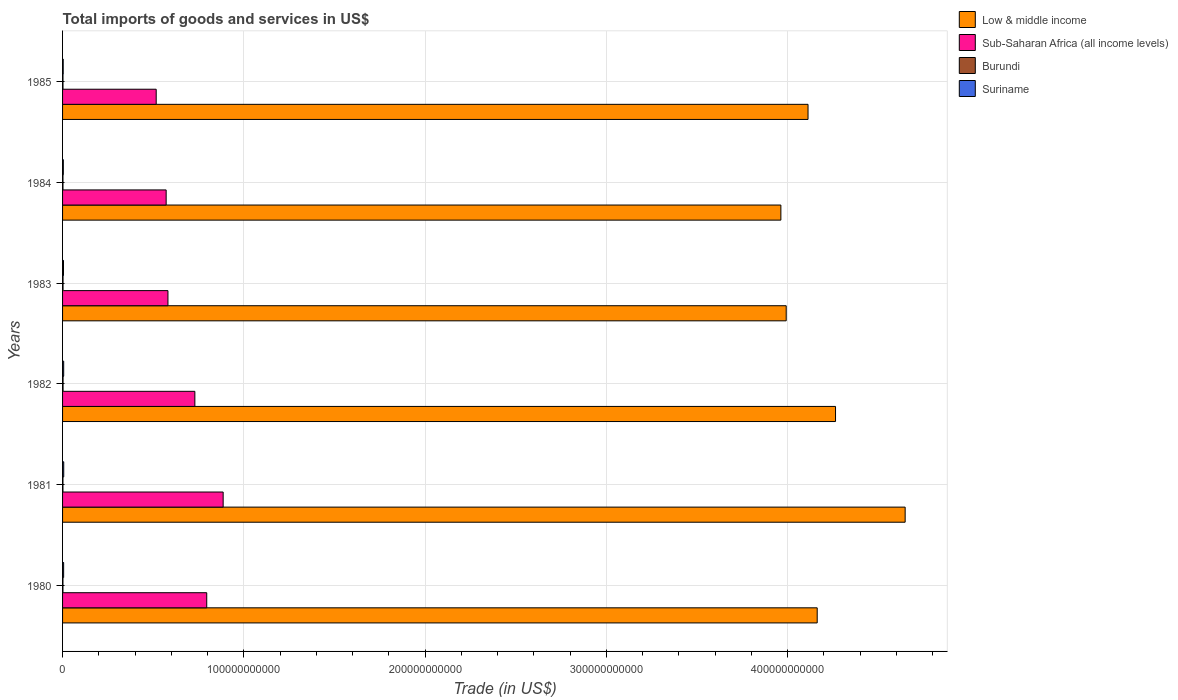How many different coloured bars are there?
Give a very brief answer. 4. How many groups of bars are there?
Ensure brevity in your answer.  6. How many bars are there on the 2nd tick from the top?
Offer a very short reply. 4. What is the total imports of goods and services in Suriname in 1981?
Offer a terse response. 6.46e+08. Across all years, what is the maximum total imports of goods and services in Burundi?
Your response must be concise. 2.73e+08. Across all years, what is the minimum total imports of goods and services in Low & middle income?
Your response must be concise. 3.96e+11. In which year was the total imports of goods and services in Sub-Saharan Africa (all income levels) minimum?
Keep it short and to the point. 1985. What is the total total imports of goods and services in Sub-Saharan Africa (all income levels) in the graph?
Your answer should be compact. 4.08e+11. What is the difference between the total imports of goods and services in Sub-Saharan Africa (all income levels) in 1982 and that in 1984?
Give a very brief answer. 1.58e+1. What is the difference between the total imports of goods and services in Suriname in 1981 and the total imports of goods and services in Sub-Saharan Africa (all income levels) in 1985?
Ensure brevity in your answer.  -5.10e+1. What is the average total imports of goods and services in Burundi per year?
Make the answer very short. 2.40e+08. In the year 1981, what is the difference between the total imports of goods and services in Sub-Saharan Africa (all income levels) and total imports of goods and services in Suriname?
Offer a terse response. 8.80e+1. In how many years, is the total imports of goods and services in Burundi greater than 60000000000 US$?
Provide a short and direct response. 0. What is the ratio of the total imports of goods and services in Low & middle income in 1981 to that in 1984?
Ensure brevity in your answer.  1.17. Is the total imports of goods and services in Sub-Saharan Africa (all income levels) in 1982 less than that in 1984?
Provide a succinct answer. No. What is the difference between the highest and the second highest total imports of goods and services in Suriname?
Provide a short and direct response. 3.05e+07. What is the difference between the highest and the lowest total imports of goods and services in Sub-Saharan Africa (all income levels)?
Give a very brief answer. 3.69e+1. In how many years, is the total imports of goods and services in Burundi greater than the average total imports of goods and services in Burundi taken over all years?
Ensure brevity in your answer.  2. What does the 4th bar from the bottom in 1981 represents?
Your answer should be compact. Suriname. Is it the case that in every year, the sum of the total imports of goods and services in Suriname and total imports of goods and services in Sub-Saharan Africa (all income levels) is greater than the total imports of goods and services in Burundi?
Your response must be concise. Yes. How many bars are there?
Keep it short and to the point. 24. Are all the bars in the graph horizontal?
Offer a very short reply. Yes. How many years are there in the graph?
Make the answer very short. 6. What is the difference between two consecutive major ticks on the X-axis?
Offer a very short reply. 1.00e+11. Does the graph contain any zero values?
Provide a short and direct response. No. Does the graph contain grids?
Make the answer very short. Yes. What is the title of the graph?
Make the answer very short. Total imports of goods and services in US$. What is the label or title of the X-axis?
Offer a very short reply. Trade (in US$). What is the Trade (in US$) of Low & middle income in 1980?
Provide a short and direct response. 4.16e+11. What is the Trade (in US$) in Sub-Saharan Africa (all income levels) in 1980?
Provide a short and direct response. 7.95e+1. What is the Trade (in US$) of Burundi in 1980?
Give a very brief answer. 2.14e+08. What is the Trade (in US$) of Suriname in 1980?
Give a very brief answer. 5.90e+08. What is the Trade (in US$) of Low & middle income in 1981?
Provide a succinct answer. 4.65e+11. What is the Trade (in US$) of Sub-Saharan Africa (all income levels) in 1981?
Make the answer very short. 8.86e+1. What is the Trade (in US$) in Burundi in 1981?
Provide a short and direct response. 2.14e+08. What is the Trade (in US$) in Suriname in 1981?
Your answer should be compact. 6.46e+08. What is the Trade (in US$) of Low & middle income in 1982?
Ensure brevity in your answer.  4.26e+11. What is the Trade (in US$) of Sub-Saharan Africa (all income levels) in 1982?
Your answer should be very brief. 7.30e+1. What is the Trade (in US$) of Burundi in 1982?
Your response must be concise. 2.73e+08. What is the Trade (in US$) of Suriname in 1982?
Offer a very short reply. 6.16e+08. What is the Trade (in US$) of Low & middle income in 1983?
Offer a very short reply. 3.99e+11. What is the Trade (in US$) in Sub-Saharan Africa (all income levels) in 1983?
Your response must be concise. 5.81e+1. What is the Trade (in US$) of Burundi in 1983?
Give a very brief answer. 2.68e+08. What is the Trade (in US$) of Suriname in 1983?
Make the answer very short. 5.18e+08. What is the Trade (in US$) of Low & middle income in 1984?
Keep it short and to the point. 3.96e+11. What is the Trade (in US$) in Sub-Saharan Africa (all income levels) in 1984?
Offer a terse response. 5.72e+1. What is the Trade (in US$) of Burundi in 1984?
Make the answer very short. 2.32e+08. What is the Trade (in US$) of Suriname in 1984?
Give a very brief answer. 4.22e+08. What is the Trade (in US$) of Low & middle income in 1985?
Offer a very short reply. 4.11e+11. What is the Trade (in US$) in Sub-Saharan Africa (all income levels) in 1985?
Keep it short and to the point. 5.17e+1. What is the Trade (in US$) in Burundi in 1985?
Your response must be concise. 2.39e+08. What is the Trade (in US$) in Suriname in 1985?
Your response must be concise. 3.48e+08. Across all years, what is the maximum Trade (in US$) of Low & middle income?
Ensure brevity in your answer.  4.65e+11. Across all years, what is the maximum Trade (in US$) in Sub-Saharan Africa (all income levels)?
Your answer should be compact. 8.86e+1. Across all years, what is the maximum Trade (in US$) in Burundi?
Provide a short and direct response. 2.73e+08. Across all years, what is the maximum Trade (in US$) of Suriname?
Ensure brevity in your answer.  6.46e+08. Across all years, what is the minimum Trade (in US$) of Low & middle income?
Give a very brief answer. 3.96e+11. Across all years, what is the minimum Trade (in US$) in Sub-Saharan Africa (all income levels)?
Ensure brevity in your answer.  5.17e+1. Across all years, what is the minimum Trade (in US$) in Burundi?
Keep it short and to the point. 2.14e+08. Across all years, what is the minimum Trade (in US$) in Suriname?
Provide a succinct answer. 3.48e+08. What is the total Trade (in US$) of Low & middle income in the graph?
Make the answer very short. 2.51e+12. What is the total Trade (in US$) of Sub-Saharan Africa (all income levels) in the graph?
Ensure brevity in your answer.  4.08e+11. What is the total Trade (in US$) of Burundi in the graph?
Your answer should be very brief. 1.44e+09. What is the total Trade (in US$) in Suriname in the graph?
Keep it short and to the point. 3.14e+09. What is the difference between the Trade (in US$) of Low & middle income in 1980 and that in 1981?
Offer a very short reply. -4.85e+1. What is the difference between the Trade (in US$) of Sub-Saharan Africa (all income levels) in 1980 and that in 1981?
Provide a short and direct response. -9.06e+09. What is the difference between the Trade (in US$) in Burundi in 1980 and that in 1981?
Keep it short and to the point. 6.68e+05. What is the difference between the Trade (in US$) of Suriname in 1980 and that in 1981?
Provide a short and direct response. -5.60e+07. What is the difference between the Trade (in US$) in Low & middle income in 1980 and that in 1982?
Your answer should be compact. -1.01e+1. What is the difference between the Trade (in US$) of Sub-Saharan Africa (all income levels) in 1980 and that in 1982?
Provide a succinct answer. 6.55e+09. What is the difference between the Trade (in US$) in Burundi in 1980 and that in 1982?
Your answer should be very brief. -5.84e+07. What is the difference between the Trade (in US$) of Suriname in 1980 and that in 1982?
Provide a short and direct response. -2.55e+07. What is the difference between the Trade (in US$) of Low & middle income in 1980 and that in 1983?
Your answer should be very brief. 1.71e+1. What is the difference between the Trade (in US$) of Sub-Saharan Africa (all income levels) in 1980 and that in 1983?
Your response must be concise. 2.14e+1. What is the difference between the Trade (in US$) in Burundi in 1980 and that in 1983?
Ensure brevity in your answer.  -5.38e+07. What is the difference between the Trade (in US$) of Suriname in 1980 and that in 1983?
Give a very brief answer. 7.24e+07. What is the difference between the Trade (in US$) in Low & middle income in 1980 and that in 1984?
Provide a short and direct response. 2.00e+1. What is the difference between the Trade (in US$) of Sub-Saharan Africa (all income levels) in 1980 and that in 1984?
Offer a very short reply. 2.24e+1. What is the difference between the Trade (in US$) of Burundi in 1980 and that in 1984?
Your answer should be compact. -1.83e+07. What is the difference between the Trade (in US$) in Suriname in 1980 and that in 1984?
Offer a very short reply. 1.68e+08. What is the difference between the Trade (in US$) of Low & middle income in 1980 and that in 1985?
Keep it short and to the point. 5.06e+09. What is the difference between the Trade (in US$) in Sub-Saharan Africa (all income levels) in 1980 and that in 1985?
Give a very brief answer. 2.79e+1. What is the difference between the Trade (in US$) in Burundi in 1980 and that in 1985?
Make the answer very short. -2.48e+07. What is the difference between the Trade (in US$) in Suriname in 1980 and that in 1985?
Give a very brief answer. 2.42e+08. What is the difference between the Trade (in US$) in Low & middle income in 1981 and that in 1982?
Make the answer very short. 3.84e+1. What is the difference between the Trade (in US$) of Sub-Saharan Africa (all income levels) in 1981 and that in 1982?
Keep it short and to the point. 1.56e+1. What is the difference between the Trade (in US$) of Burundi in 1981 and that in 1982?
Offer a very short reply. -5.91e+07. What is the difference between the Trade (in US$) of Suriname in 1981 and that in 1982?
Keep it short and to the point. 3.05e+07. What is the difference between the Trade (in US$) of Low & middle income in 1981 and that in 1983?
Make the answer very short. 6.56e+1. What is the difference between the Trade (in US$) of Sub-Saharan Africa (all income levels) in 1981 and that in 1983?
Offer a terse response. 3.05e+1. What is the difference between the Trade (in US$) of Burundi in 1981 and that in 1983?
Your answer should be very brief. -5.44e+07. What is the difference between the Trade (in US$) of Suriname in 1981 and that in 1983?
Your answer should be compact. 1.28e+08. What is the difference between the Trade (in US$) of Low & middle income in 1981 and that in 1984?
Provide a succinct answer. 6.86e+1. What is the difference between the Trade (in US$) in Sub-Saharan Africa (all income levels) in 1981 and that in 1984?
Your answer should be very brief. 3.14e+1. What is the difference between the Trade (in US$) in Burundi in 1981 and that in 1984?
Your answer should be compact. -1.89e+07. What is the difference between the Trade (in US$) of Suriname in 1981 and that in 1984?
Keep it short and to the point. 2.24e+08. What is the difference between the Trade (in US$) of Low & middle income in 1981 and that in 1985?
Your answer should be compact. 5.36e+1. What is the difference between the Trade (in US$) of Sub-Saharan Africa (all income levels) in 1981 and that in 1985?
Your answer should be very brief. 3.69e+1. What is the difference between the Trade (in US$) in Burundi in 1981 and that in 1985?
Your answer should be compact. -2.55e+07. What is the difference between the Trade (in US$) of Suriname in 1981 and that in 1985?
Give a very brief answer. 2.98e+08. What is the difference between the Trade (in US$) in Low & middle income in 1982 and that in 1983?
Provide a succinct answer. 2.72e+1. What is the difference between the Trade (in US$) of Sub-Saharan Africa (all income levels) in 1982 and that in 1983?
Provide a short and direct response. 1.49e+1. What is the difference between the Trade (in US$) in Burundi in 1982 and that in 1983?
Offer a very short reply. 4.63e+06. What is the difference between the Trade (in US$) in Suriname in 1982 and that in 1983?
Offer a terse response. 9.80e+07. What is the difference between the Trade (in US$) in Low & middle income in 1982 and that in 1984?
Offer a very short reply. 3.02e+1. What is the difference between the Trade (in US$) of Sub-Saharan Africa (all income levels) in 1982 and that in 1984?
Offer a very short reply. 1.58e+1. What is the difference between the Trade (in US$) of Burundi in 1982 and that in 1984?
Offer a terse response. 4.01e+07. What is the difference between the Trade (in US$) in Suriname in 1982 and that in 1984?
Offer a terse response. 1.94e+08. What is the difference between the Trade (in US$) of Low & middle income in 1982 and that in 1985?
Ensure brevity in your answer.  1.52e+1. What is the difference between the Trade (in US$) in Sub-Saharan Africa (all income levels) in 1982 and that in 1985?
Give a very brief answer. 2.13e+1. What is the difference between the Trade (in US$) of Burundi in 1982 and that in 1985?
Provide a succinct answer. 3.36e+07. What is the difference between the Trade (in US$) in Suriname in 1982 and that in 1985?
Offer a very short reply. 2.67e+08. What is the difference between the Trade (in US$) of Low & middle income in 1983 and that in 1984?
Your response must be concise. 2.94e+09. What is the difference between the Trade (in US$) in Sub-Saharan Africa (all income levels) in 1983 and that in 1984?
Give a very brief answer. 9.88e+08. What is the difference between the Trade (in US$) in Burundi in 1983 and that in 1984?
Provide a short and direct response. 3.55e+07. What is the difference between the Trade (in US$) of Suriname in 1983 and that in 1984?
Make the answer very short. 9.60e+07. What is the difference between the Trade (in US$) of Low & middle income in 1983 and that in 1985?
Keep it short and to the point. -1.20e+1. What is the difference between the Trade (in US$) of Sub-Saharan Africa (all income levels) in 1983 and that in 1985?
Offer a terse response. 6.48e+09. What is the difference between the Trade (in US$) of Burundi in 1983 and that in 1985?
Your response must be concise. 2.90e+07. What is the difference between the Trade (in US$) of Suriname in 1983 and that in 1985?
Ensure brevity in your answer.  1.69e+08. What is the difference between the Trade (in US$) of Low & middle income in 1984 and that in 1985?
Your response must be concise. -1.50e+1. What is the difference between the Trade (in US$) in Sub-Saharan Africa (all income levels) in 1984 and that in 1985?
Offer a very short reply. 5.49e+09. What is the difference between the Trade (in US$) of Burundi in 1984 and that in 1985?
Your answer should be compact. -6.55e+06. What is the difference between the Trade (in US$) of Suriname in 1984 and that in 1985?
Offer a terse response. 7.31e+07. What is the difference between the Trade (in US$) in Low & middle income in 1980 and the Trade (in US$) in Sub-Saharan Africa (all income levels) in 1981?
Your response must be concise. 3.28e+11. What is the difference between the Trade (in US$) in Low & middle income in 1980 and the Trade (in US$) in Burundi in 1981?
Your response must be concise. 4.16e+11. What is the difference between the Trade (in US$) of Low & middle income in 1980 and the Trade (in US$) of Suriname in 1981?
Keep it short and to the point. 4.16e+11. What is the difference between the Trade (in US$) of Sub-Saharan Africa (all income levels) in 1980 and the Trade (in US$) of Burundi in 1981?
Ensure brevity in your answer.  7.93e+1. What is the difference between the Trade (in US$) in Sub-Saharan Africa (all income levels) in 1980 and the Trade (in US$) in Suriname in 1981?
Provide a succinct answer. 7.89e+1. What is the difference between the Trade (in US$) of Burundi in 1980 and the Trade (in US$) of Suriname in 1981?
Your answer should be compact. -4.32e+08. What is the difference between the Trade (in US$) in Low & middle income in 1980 and the Trade (in US$) in Sub-Saharan Africa (all income levels) in 1982?
Your answer should be compact. 3.43e+11. What is the difference between the Trade (in US$) of Low & middle income in 1980 and the Trade (in US$) of Burundi in 1982?
Keep it short and to the point. 4.16e+11. What is the difference between the Trade (in US$) of Low & middle income in 1980 and the Trade (in US$) of Suriname in 1982?
Your answer should be compact. 4.16e+11. What is the difference between the Trade (in US$) in Sub-Saharan Africa (all income levels) in 1980 and the Trade (in US$) in Burundi in 1982?
Provide a succinct answer. 7.93e+1. What is the difference between the Trade (in US$) of Sub-Saharan Africa (all income levels) in 1980 and the Trade (in US$) of Suriname in 1982?
Offer a very short reply. 7.89e+1. What is the difference between the Trade (in US$) of Burundi in 1980 and the Trade (in US$) of Suriname in 1982?
Your answer should be compact. -4.01e+08. What is the difference between the Trade (in US$) in Low & middle income in 1980 and the Trade (in US$) in Sub-Saharan Africa (all income levels) in 1983?
Your response must be concise. 3.58e+11. What is the difference between the Trade (in US$) in Low & middle income in 1980 and the Trade (in US$) in Burundi in 1983?
Ensure brevity in your answer.  4.16e+11. What is the difference between the Trade (in US$) in Low & middle income in 1980 and the Trade (in US$) in Suriname in 1983?
Make the answer very short. 4.16e+11. What is the difference between the Trade (in US$) in Sub-Saharan Africa (all income levels) in 1980 and the Trade (in US$) in Burundi in 1983?
Give a very brief answer. 7.93e+1. What is the difference between the Trade (in US$) of Sub-Saharan Africa (all income levels) in 1980 and the Trade (in US$) of Suriname in 1983?
Ensure brevity in your answer.  7.90e+1. What is the difference between the Trade (in US$) in Burundi in 1980 and the Trade (in US$) in Suriname in 1983?
Your response must be concise. -3.03e+08. What is the difference between the Trade (in US$) in Low & middle income in 1980 and the Trade (in US$) in Sub-Saharan Africa (all income levels) in 1984?
Offer a very short reply. 3.59e+11. What is the difference between the Trade (in US$) in Low & middle income in 1980 and the Trade (in US$) in Burundi in 1984?
Provide a succinct answer. 4.16e+11. What is the difference between the Trade (in US$) of Low & middle income in 1980 and the Trade (in US$) of Suriname in 1984?
Provide a succinct answer. 4.16e+11. What is the difference between the Trade (in US$) of Sub-Saharan Africa (all income levels) in 1980 and the Trade (in US$) of Burundi in 1984?
Ensure brevity in your answer.  7.93e+1. What is the difference between the Trade (in US$) of Sub-Saharan Africa (all income levels) in 1980 and the Trade (in US$) of Suriname in 1984?
Your answer should be very brief. 7.91e+1. What is the difference between the Trade (in US$) in Burundi in 1980 and the Trade (in US$) in Suriname in 1984?
Offer a terse response. -2.07e+08. What is the difference between the Trade (in US$) in Low & middle income in 1980 and the Trade (in US$) in Sub-Saharan Africa (all income levels) in 1985?
Provide a short and direct response. 3.65e+11. What is the difference between the Trade (in US$) of Low & middle income in 1980 and the Trade (in US$) of Burundi in 1985?
Your response must be concise. 4.16e+11. What is the difference between the Trade (in US$) of Low & middle income in 1980 and the Trade (in US$) of Suriname in 1985?
Ensure brevity in your answer.  4.16e+11. What is the difference between the Trade (in US$) of Sub-Saharan Africa (all income levels) in 1980 and the Trade (in US$) of Burundi in 1985?
Offer a very short reply. 7.93e+1. What is the difference between the Trade (in US$) of Sub-Saharan Africa (all income levels) in 1980 and the Trade (in US$) of Suriname in 1985?
Provide a succinct answer. 7.92e+1. What is the difference between the Trade (in US$) in Burundi in 1980 and the Trade (in US$) in Suriname in 1985?
Provide a succinct answer. -1.34e+08. What is the difference between the Trade (in US$) in Low & middle income in 1981 and the Trade (in US$) in Sub-Saharan Africa (all income levels) in 1982?
Give a very brief answer. 3.92e+11. What is the difference between the Trade (in US$) in Low & middle income in 1981 and the Trade (in US$) in Burundi in 1982?
Ensure brevity in your answer.  4.65e+11. What is the difference between the Trade (in US$) in Low & middle income in 1981 and the Trade (in US$) in Suriname in 1982?
Your response must be concise. 4.64e+11. What is the difference between the Trade (in US$) in Sub-Saharan Africa (all income levels) in 1981 and the Trade (in US$) in Burundi in 1982?
Ensure brevity in your answer.  8.83e+1. What is the difference between the Trade (in US$) of Sub-Saharan Africa (all income levels) in 1981 and the Trade (in US$) of Suriname in 1982?
Keep it short and to the point. 8.80e+1. What is the difference between the Trade (in US$) of Burundi in 1981 and the Trade (in US$) of Suriname in 1982?
Your answer should be very brief. -4.02e+08. What is the difference between the Trade (in US$) in Low & middle income in 1981 and the Trade (in US$) in Sub-Saharan Africa (all income levels) in 1983?
Your answer should be compact. 4.07e+11. What is the difference between the Trade (in US$) in Low & middle income in 1981 and the Trade (in US$) in Burundi in 1983?
Provide a short and direct response. 4.65e+11. What is the difference between the Trade (in US$) in Low & middle income in 1981 and the Trade (in US$) in Suriname in 1983?
Make the answer very short. 4.64e+11. What is the difference between the Trade (in US$) of Sub-Saharan Africa (all income levels) in 1981 and the Trade (in US$) of Burundi in 1983?
Offer a terse response. 8.83e+1. What is the difference between the Trade (in US$) in Sub-Saharan Africa (all income levels) in 1981 and the Trade (in US$) in Suriname in 1983?
Provide a succinct answer. 8.81e+1. What is the difference between the Trade (in US$) in Burundi in 1981 and the Trade (in US$) in Suriname in 1983?
Ensure brevity in your answer.  -3.04e+08. What is the difference between the Trade (in US$) of Low & middle income in 1981 and the Trade (in US$) of Sub-Saharan Africa (all income levels) in 1984?
Ensure brevity in your answer.  4.08e+11. What is the difference between the Trade (in US$) in Low & middle income in 1981 and the Trade (in US$) in Burundi in 1984?
Your answer should be very brief. 4.65e+11. What is the difference between the Trade (in US$) of Low & middle income in 1981 and the Trade (in US$) of Suriname in 1984?
Keep it short and to the point. 4.64e+11. What is the difference between the Trade (in US$) of Sub-Saharan Africa (all income levels) in 1981 and the Trade (in US$) of Burundi in 1984?
Your answer should be very brief. 8.84e+1. What is the difference between the Trade (in US$) of Sub-Saharan Africa (all income levels) in 1981 and the Trade (in US$) of Suriname in 1984?
Your response must be concise. 8.82e+1. What is the difference between the Trade (in US$) of Burundi in 1981 and the Trade (in US$) of Suriname in 1984?
Provide a succinct answer. -2.08e+08. What is the difference between the Trade (in US$) of Low & middle income in 1981 and the Trade (in US$) of Sub-Saharan Africa (all income levels) in 1985?
Provide a short and direct response. 4.13e+11. What is the difference between the Trade (in US$) in Low & middle income in 1981 and the Trade (in US$) in Burundi in 1985?
Make the answer very short. 4.65e+11. What is the difference between the Trade (in US$) of Low & middle income in 1981 and the Trade (in US$) of Suriname in 1985?
Give a very brief answer. 4.65e+11. What is the difference between the Trade (in US$) in Sub-Saharan Africa (all income levels) in 1981 and the Trade (in US$) in Burundi in 1985?
Your answer should be very brief. 8.84e+1. What is the difference between the Trade (in US$) in Sub-Saharan Africa (all income levels) in 1981 and the Trade (in US$) in Suriname in 1985?
Your response must be concise. 8.83e+1. What is the difference between the Trade (in US$) of Burundi in 1981 and the Trade (in US$) of Suriname in 1985?
Make the answer very short. -1.35e+08. What is the difference between the Trade (in US$) of Low & middle income in 1982 and the Trade (in US$) of Sub-Saharan Africa (all income levels) in 1983?
Your response must be concise. 3.68e+11. What is the difference between the Trade (in US$) in Low & middle income in 1982 and the Trade (in US$) in Burundi in 1983?
Your response must be concise. 4.26e+11. What is the difference between the Trade (in US$) of Low & middle income in 1982 and the Trade (in US$) of Suriname in 1983?
Offer a terse response. 4.26e+11. What is the difference between the Trade (in US$) of Sub-Saharan Africa (all income levels) in 1982 and the Trade (in US$) of Burundi in 1983?
Your answer should be very brief. 7.27e+1. What is the difference between the Trade (in US$) in Sub-Saharan Africa (all income levels) in 1982 and the Trade (in US$) in Suriname in 1983?
Provide a succinct answer. 7.25e+1. What is the difference between the Trade (in US$) in Burundi in 1982 and the Trade (in US$) in Suriname in 1983?
Keep it short and to the point. -2.45e+08. What is the difference between the Trade (in US$) of Low & middle income in 1982 and the Trade (in US$) of Sub-Saharan Africa (all income levels) in 1984?
Give a very brief answer. 3.69e+11. What is the difference between the Trade (in US$) of Low & middle income in 1982 and the Trade (in US$) of Burundi in 1984?
Provide a succinct answer. 4.26e+11. What is the difference between the Trade (in US$) of Low & middle income in 1982 and the Trade (in US$) of Suriname in 1984?
Your answer should be very brief. 4.26e+11. What is the difference between the Trade (in US$) in Sub-Saharan Africa (all income levels) in 1982 and the Trade (in US$) in Burundi in 1984?
Give a very brief answer. 7.28e+1. What is the difference between the Trade (in US$) of Sub-Saharan Africa (all income levels) in 1982 and the Trade (in US$) of Suriname in 1984?
Your answer should be very brief. 7.26e+1. What is the difference between the Trade (in US$) of Burundi in 1982 and the Trade (in US$) of Suriname in 1984?
Keep it short and to the point. -1.49e+08. What is the difference between the Trade (in US$) in Low & middle income in 1982 and the Trade (in US$) in Sub-Saharan Africa (all income levels) in 1985?
Your answer should be compact. 3.75e+11. What is the difference between the Trade (in US$) of Low & middle income in 1982 and the Trade (in US$) of Burundi in 1985?
Provide a succinct answer. 4.26e+11. What is the difference between the Trade (in US$) of Low & middle income in 1982 and the Trade (in US$) of Suriname in 1985?
Offer a very short reply. 4.26e+11. What is the difference between the Trade (in US$) of Sub-Saharan Africa (all income levels) in 1982 and the Trade (in US$) of Burundi in 1985?
Provide a short and direct response. 7.28e+1. What is the difference between the Trade (in US$) in Sub-Saharan Africa (all income levels) in 1982 and the Trade (in US$) in Suriname in 1985?
Keep it short and to the point. 7.26e+1. What is the difference between the Trade (in US$) of Burundi in 1982 and the Trade (in US$) of Suriname in 1985?
Offer a terse response. -7.58e+07. What is the difference between the Trade (in US$) in Low & middle income in 1983 and the Trade (in US$) in Sub-Saharan Africa (all income levels) in 1984?
Give a very brief answer. 3.42e+11. What is the difference between the Trade (in US$) of Low & middle income in 1983 and the Trade (in US$) of Burundi in 1984?
Offer a terse response. 3.99e+11. What is the difference between the Trade (in US$) in Low & middle income in 1983 and the Trade (in US$) in Suriname in 1984?
Offer a very short reply. 3.99e+11. What is the difference between the Trade (in US$) in Sub-Saharan Africa (all income levels) in 1983 and the Trade (in US$) in Burundi in 1984?
Offer a very short reply. 5.79e+1. What is the difference between the Trade (in US$) in Sub-Saharan Africa (all income levels) in 1983 and the Trade (in US$) in Suriname in 1984?
Provide a short and direct response. 5.77e+1. What is the difference between the Trade (in US$) in Burundi in 1983 and the Trade (in US$) in Suriname in 1984?
Your response must be concise. -1.54e+08. What is the difference between the Trade (in US$) of Low & middle income in 1983 and the Trade (in US$) of Sub-Saharan Africa (all income levels) in 1985?
Your answer should be very brief. 3.48e+11. What is the difference between the Trade (in US$) of Low & middle income in 1983 and the Trade (in US$) of Burundi in 1985?
Provide a succinct answer. 3.99e+11. What is the difference between the Trade (in US$) in Low & middle income in 1983 and the Trade (in US$) in Suriname in 1985?
Your answer should be very brief. 3.99e+11. What is the difference between the Trade (in US$) in Sub-Saharan Africa (all income levels) in 1983 and the Trade (in US$) in Burundi in 1985?
Give a very brief answer. 5.79e+1. What is the difference between the Trade (in US$) of Sub-Saharan Africa (all income levels) in 1983 and the Trade (in US$) of Suriname in 1985?
Make the answer very short. 5.78e+1. What is the difference between the Trade (in US$) in Burundi in 1983 and the Trade (in US$) in Suriname in 1985?
Provide a short and direct response. -8.04e+07. What is the difference between the Trade (in US$) in Low & middle income in 1984 and the Trade (in US$) in Sub-Saharan Africa (all income levels) in 1985?
Keep it short and to the point. 3.45e+11. What is the difference between the Trade (in US$) in Low & middle income in 1984 and the Trade (in US$) in Burundi in 1985?
Your response must be concise. 3.96e+11. What is the difference between the Trade (in US$) in Low & middle income in 1984 and the Trade (in US$) in Suriname in 1985?
Your answer should be very brief. 3.96e+11. What is the difference between the Trade (in US$) in Sub-Saharan Africa (all income levels) in 1984 and the Trade (in US$) in Burundi in 1985?
Offer a terse response. 5.69e+1. What is the difference between the Trade (in US$) in Sub-Saharan Africa (all income levels) in 1984 and the Trade (in US$) in Suriname in 1985?
Offer a terse response. 5.68e+1. What is the difference between the Trade (in US$) in Burundi in 1984 and the Trade (in US$) in Suriname in 1985?
Your answer should be very brief. -1.16e+08. What is the average Trade (in US$) in Low & middle income per year?
Ensure brevity in your answer.  4.19e+11. What is the average Trade (in US$) of Sub-Saharan Africa (all income levels) per year?
Offer a terse response. 6.80e+1. What is the average Trade (in US$) in Burundi per year?
Your answer should be very brief. 2.40e+08. What is the average Trade (in US$) of Suriname per year?
Your answer should be compact. 5.23e+08. In the year 1980, what is the difference between the Trade (in US$) of Low & middle income and Trade (in US$) of Sub-Saharan Africa (all income levels)?
Your answer should be very brief. 3.37e+11. In the year 1980, what is the difference between the Trade (in US$) of Low & middle income and Trade (in US$) of Burundi?
Provide a short and direct response. 4.16e+11. In the year 1980, what is the difference between the Trade (in US$) of Low & middle income and Trade (in US$) of Suriname?
Your answer should be very brief. 4.16e+11. In the year 1980, what is the difference between the Trade (in US$) in Sub-Saharan Africa (all income levels) and Trade (in US$) in Burundi?
Give a very brief answer. 7.93e+1. In the year 1980, what is the difference between the Trade (in US$) in Sub-Saharan Africa (all income levels) and Trade (in US$) in Suriname?
Your answer should be compact. 7.90e+1. In the year 1980, what is the difference between the Trade (in US$) in Burundi and Trade (in US$) in Suriname?
Your response must be concise. -3.76e+08. In the year 1981, what is the difference between the Trade (in US$) in Low & middle income and Trade (in US$) in Sub-Saharan Africa (all income levels)?
Ensure brevity in your answer.  3.76e+11. In the year 1981, what is the difference between the Trade (in US$) in Low & middle income and Trade (in US$) in Burundi?
Make the answer very short. 4.65e+11. In the year 1981, what is the difference between the Trade (in US$) of Low & middle income and Trade (in US$) of Suriname?
Provide a short and direct response. 4.64e+11. In the year 1981, what is the difference between the Trade (in US$) in Sub-Saharan Africa (all income levels) and Trade (in US$) in Burundi?
Your answer should be compact. 8.84e+1. In the year 1981, what is the difference between the Trade (in US$) of Sub-Saharan Africa (all income levels) and Trade (in US$) of Suriname?
Your response must be concise. 8.80e+1. In the year 1981, what is the difference between the Trade (in US$) of Burundi and Trade (in US$) of Suriname?
Provide a succinct answer. -4.32e+08. In the year 1982, what is the difference between the Trade (in US$) in Low & middle income and Trade (in US$) in Sub-Saharan Africa (all income levels)?
Your answer should be very brief. 3.53e+11. In the year 1982, what is the difference between the Trade (in US$) of Low & middle income and Trade (in US$) of Burundi?
Your answer should be compact. 4.26e+11. In the year 1982, what is the difference between the Trade (in US$) in Low & middle income and Trade (in US$) in Suriname?
Your response must be concise. 4.26e+11. In the year 1982, what is the difference between the Trade (in US$) of Sub-Saharan Africa (all income levels) and Trade (in US$) of Burundi?
Provide a short and direct response. 7.27e+1. In the year 1982, what is the difference between the Trade (in US$) of Sub-Saharan Africa (all income levels) and Trade (in US$) of Suriname?
Ensure brevity in your answer.  7.24e+1. In the year 1982, what is the difference between the Trade (in US$) in Burundi and Trade (in US$) in Suriname?
Provide a short and direct response. -3.43e+08. In the year 1983, what is the difference between the Trade (in US$) of Low & middle income and Trade (in US$) of Sub-Saharan Africa (all income levels)?
Your answer should be very brief. 3.41e+11. In the year 1983, what is the difference between the Trade (in US$) of Low & middle income and Trade (in US$) of Burundi?
Offer a terse response. 3.99e+11. In the year 1983, what is the difference between the Trade (in US$) in Low & middle income and Trade (in US$) in Suriname?
Ensure brevity in your answer.  3.99e+11. In the year 1983, what is the difference between the Trade (in US$) in Sub-Saharan Africa (all income levels) and Trade (in US$) in Burundi?
Offer a terse response. 5.79e+1. In the year 1983, what is the difference between the Trade (in US$) in Sub-Saharan Africa (all income levels) and Trade (in US$) in Suriname?
Your response must be concise. 5.76e+1. In the year 1983, what is the difference between the Trade (in US$) of Burundi and Trade (in US$) of Suriname?
Your answer should be very brief. -2.50e+08. In the year 1984, what is the difference between the Trade (in US$) in Low & middle income and Trade (in US$) in Sub-Saharan Africa (all income levels)?
Ensure brevity in your answer.  3.39e+11. In the year 1984, what is the difference between the Trade (in US$) of Low & middle income and Trade (in US$) of Burundi?
Your response must be concise. 3.96e+11. In the year 1984, what is the difference between the Trade (in US$) of Low & middle income and Trade (in US$) of Suriname?
Provide a short and direct response. 3.96e+11. In the year 1984, what is the difference between the Trade (in US$) in Sub-Saharan Africa (all income levels) and Trade (in US$) in Burundi?
Keep it short and to the point. 5.69e+1. In the year 1984, what is the difference between the Trade (in US$) in Sub-Saharan Africa (all income levels) and Trade (in US$) in Suriname?
Provide a short and direct response. 5.67e+1. In the year 1984, what is the difference between the Trade (in US$) of Burundi and Trade (in US$) of Suriname?
Give a very brief answer. -1.89e+08. In the year 1985, what is the difference between the Trade (in US$) in Low & middle income and Trade (in US$) in Sub-Saharan Africa (all income levels)?
Offer a terse response. 3.60e+11. In the year 1985, what is the difference between the Trade (in US$) of Low & middle income and Trade (in US$) of Burundi?
Provide a succinct answer. 4.11e+11. In the year 1985, what is the difference between the Trade (in US$) in Low & middle income and Trade (in US$) in Suriname?
Offer a terse response. 4.11e+11. In the year 1985, what is the difference between the Trade (in US$) in Sub-Saharan Africa (all income levels) and Trade (in US$) in Burundi?
Provide a succinct answer. 5.14e+1. In the year 1985, what is the difference between the Trade (in US$) in Sub-Saharan Africa (all income levels) and Trade (in US$) in Suriname?
Your response must be concise. 5.13e+1. In the year 1985, what is the difference between the Trade (in US$) in Burundi and Trade (in US$) in Suriname?
Provide a succinct answer. -1.09e+08. What is the ratio of the Trade (in US$) in Low & middle income in 1980 to that in 1981?
Ensure brevity in your answer.  0.9. What is the ratio of the Trade (in US$) in Sub-Saharan Africa (all income levels) in 1980 to that in 1981?
Your answer should be compact. 0.9. What is the ratio of the Trade (in US$) in Burundi in 1980 to that in 1981?
Your answer should be very brief. 1. What is the ratio of the Trade (in US$) of Suriname in 1980 to that in 1981?
Make the answer very short. 0.91. What is the ratio of the Trade (in US$) of Low & middle income in 1980 to that in 1982?
Offer a very short reply. 0.98. What is the ratio of the Trade (in US$) in Sub-Saharan Africa (all income levels) in 1980 to that in 1982?
Provide a short and direct response. 1.09. What is the ratio of the Trade (in US$) in Burundi in 1980 to that in 1982?
Ensure brevity in your answer.  0.79. What is the ratio of the Trade (in US$) in Suriname in 1980 to that in 1982?
Make the answer very short. 0.96. What is the ratio of the Trade (in US$) in Low & middle income in 1980 to that in 1983?
Keep it short and to the point. 1.04. What is the ratio of the Trade (in US$) in Sub-Saharan Africa (all income levels) in 1980 to that in 1983?
Offer a very short reply. 1.37. What is the ratio of the Trade (in US$) in Burundi in 1980 to that in 1983?
Your answer should be compact. 0.8. What is the ratio of the Trade (in US$) of Suriname in 1980 to that in 1983?
Provide a short and direct response. 1.14. What is the ratio of the Trade (in US$) in Low & middle income in 1980 to that in 1984?
Offer a very short reply. 1.05. What is the ratio of the Trade (in US$) in Sub-Saharan Africa (all income levels) in 1980 to that in 1984?
Offer a very short reply. 1.39. What is the ratio of the Trade (in US$) in Burundi in 1980 to that in 1984?
Offer a very short reply. 0.92. What is the ratio of the Trade (in US$) of Suriname in 1980 to that in 1984?
Give a very brief answer. 1.4. What is the ratio of the Trade (in US$) in Low & middle income in 1980 to that in 1985?
Offer a terse response. 1.01. What is the ratio of the Trade (in US$) of Sub-Saharan Africa (all income levels) in 1980 to that in 1985?
Keep it short and to the point. 1.54. What is the ratio of the Trade (in US$) of Burundi in 1980 to that in 1985?
Make the answer very short. 0.9. What is the ratio of the Trade (in US$) in Suriname in 1980 to that in 1985?
Provide a succinct answer. 1.69. What is the ratio of the Trade (in US$) in Low & middle income in 1981 to that in 1982?
Provide a short and direct response. 1.09. What is the ratio of the Trade (in US$) of Sub-Saharan Africa (all income levels) in 1981 to that in 1982?
Offer a terse response. 1.21. What is the ratio of the Trade (in US$) of Burundi in 1981 to that in 1982?
Offer a terse response. 0.78. What is the ratio of the Trade (in US$) of Suriname in 1981 to that in 1982?
Your answer should be compact. 1.05. What is the ratio of the Trade (in US$) in Low & middle income in 1981 to that in 1983?
Offer a terse response. 1.16. What is the ratio of the Trade (in US$) in Sub-Saharan Africa (all income levels) in 1981 to that in 1983?
Make the answer very short. 1.52. What is the ratio of the Trade (in US$) of Burundi in 1981 to that in 1983?
Give a very brief answer. 0.8. What is the ratio of the Trade (in US$) of Suriname in 1981 to that in 1983?
Offer a terse response. 1.25. What is the ratio of the Trade (in US$) of Low & middle income in 1981 to that in 1984?
Offer a terse response. 1.17. What is the ratio of the Trade (in US$) of Sub-Saharan Africa (all income levels) in 1981 to that in 1984?
Ensure brevity in your answer.  1.55. What is the ratio of the Trade (in US$) in Burundi in 1981 to that in 1984?
Keep it short and to the point. 0.92. What is the ratio of the Trade (in US$) of Suriname in 1981 to that in 1984?
Give a very brief answer. 1.53. What is the ratio of the Trade (in US$) in Low & middle income in 1981 to that in 1985?
Offer a terse response. 1.13. What is the ratio of the Trade (in US$) in Sub-Saharan Africa (all income levels) in 1981 to that in 1985?
Your answer should be very brief. 1.72. What is the ratio of the Trade (in US$) of Burundi in 1981 to that in 1985?
Offer a very short reply. 0.89. What is the ratio of the Trade (in US$) of Suriname in 1981 to that in 1985?
Your answer should be compact. 1.85. What is the ratio of the Trade (in US$) of Low & middle income in 1982 to that in 1983?
Provide a short and direct response. 1.07. What is the ratio of the Trade (in US$) in Sub-Saharan Africa (all income levels) in 1982 to that in 1983?
Ensure brevity in your answer.  1.26. What is the ratio of the Trade (in US$) of Burundi in 1982 to that in 1983?
Your answer should be compact. 1.02. What is the ratio of the Trade (in US$) of Suriname in 1982 to that in 1983?
Ensure brevity in your answer.  1.19. What is the ratio of the Trade (in US$) in Low & middle income in 1982 to that in 1984?
Offer a very short reply. 1.08. What is the ratio of the Trade (in US$) in Sub-Saharan Africa (all income levels) in 1982 to that in 1984?
Provide a short and direct response. 1.28. What is the ratio of the Trade (in US$) in Burundi in 1982 to that in 1984?
Provide a short and direct response. 1.17. What is the ratio of the Trade (in US$) of Suriname in 1982 to that in 1984?
Your answer should be compact. 1.46. What is the ratio of the Trade (in US$) in Low & middle income in 1982 to that in 1985?
Offer a very short reply. 1.04. What is the ratio of the Trade (in US$) in Sub-Saharan Africa (all income levels) in 1982 to that in 1985?
Make the answer very short. 1.41. What is the ratio of the Trade (in US$) of Burundi in 1982 to that in 1985?
Give a very brief answer. 1.14. What is the ratio of the Trade (in US$) of Suriname in 1982 to that in 1985?
Your response must be concise. 1.77. What is the ratio of the Trade (in US$) in Low & middle income in 1983 to that in 1984?
Offer a very short reply. 1.01. What is the ratio of the Trade (in US$) of Sub-Saharan Africa (all income levels) in 1983 to that in 1984?
Offer a very short reply. 1.02. What is the ratio of the Trade (in US$) of Burundi in 1983 to that in 1984?
Offer a terse response. 1.15. What is the ratio of the Trade (in US$) of Suriname in 1983 to that in 1984?
Give a very brief answer. 1.23. What is the ratio of the Trade (in US$) in Low & middle income in 1983 to that in 1985?
Provide a short and direct response. 0.97. What is the ratio of the Trade (in US$) in Sub-Saharan Africa (all income levels) in 1983 to that in 1985?
Your answer should be very brief. 1.13. What is the ratio of the Trade (in US$) in Burundi in 1983 to that in 1985?
Your answer should be compact. 1.12. What is the ratio of the Trade (in US$) in Suriname in 1983 to that in 1985?
Offer a very short reply. 1.49. What is the ratio of the Trade (in US$) of Low & middle income in 1984 to that in 1985?
Your answer should be compact. 0.96. What is the ratio of the Trade (in US$) of Sub-Saharan Africa (all income levels) in 1984 to that in 1985?
Keep it short and to the point. 1.11. What is the ratio of the Trade (in US$) in Burundi in 1984 to that in 1985?
Your response must be concise. 0.97. What is the ratio of the Trade (in US$) of Suriname in 1984 to that in 1985?
Give a very brief answer. 1.21. What is the difference between the highest and the second highest Trade (in US$) of Low & middle income?
Make the answer very short. 3.84e+1. What is the difference between the highest and the second highest Trade (in US$) in Sub-Saharan Africa (all income levels)?
Provide a short and direct response. 9.06e+09. What is the difference between the highest and the second highest Trade (in US$) in Burundi?
Your response must be concise. 4.63e+06. What is the difference between the highest and the second highest Trade (in US$) of Suriname?
Ensure brevity in your answer.  3.05e+07. What is the difference between the highest and the lowest Trade (in US$) of Low & middle income?
Your response must be concise. 6.86e+1. What is the difference between the highest and the lowest Trade (in US$) in Sub-Saharan Africa (all income levels)?
Give a very brief answer. 3.69e+1. What is the difference between the highest and the lowest Trade (in US$) of Burundi?
Offer a terse response. 5.91e+07. What is the difference between the highest and the lowest Trade (in US$) in Suriname?
Keep it short and to the point. 2.98e+08. 